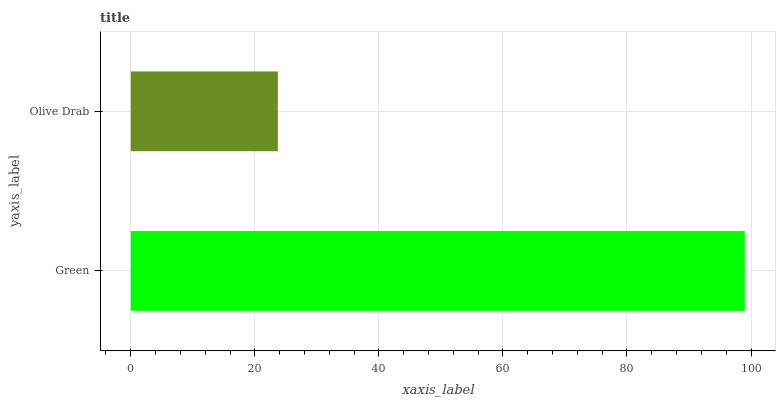Is Olive Drab the minimum?
Answer yes or no. Yes. Is Green the maximum?
Answer yes or no. Yes. Is Olive Drab the maximum?
Answer yes or no. No. Is Green greater than Olive Drab?
Answer yes or no. Yes. Is Olive Drab less than Green?
Answer yes or no. Yes. Is Olive Drab greater than Green?
Answer yes or no. No. Is Green less than Olive Drab?
Answer yes or no. No. Is Green the high median?
Answer yes or no. Yes. Is Olive Drab the low median?
Answer yes or no. Yes. Is Olive Drab the high median?
Answer yes or no. No. Is Green the low median?
Answer yes or no. No. 